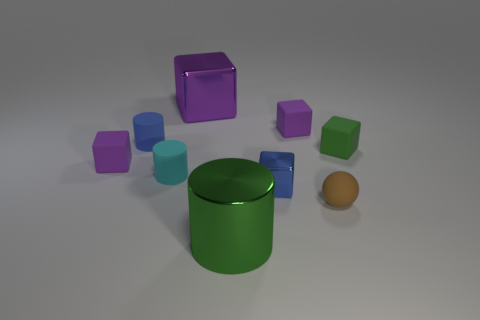Subtract all blue spheres. How many purple blocks are left? 3 Add 1 tiny blue cylinders. How many objects exist? 10 Subtract all cylinders. How many objects are left? 6 Subtract 1 blue blocks. How many objects are left? 8 Subtract all green rubber balls. Subtract all small green rubber things. How many objects are left? 8 Add 7 brown things. How many brown things are left? 8 Add 1 tiny blue cylinders. How many tiny blue cylinders exist? 2 